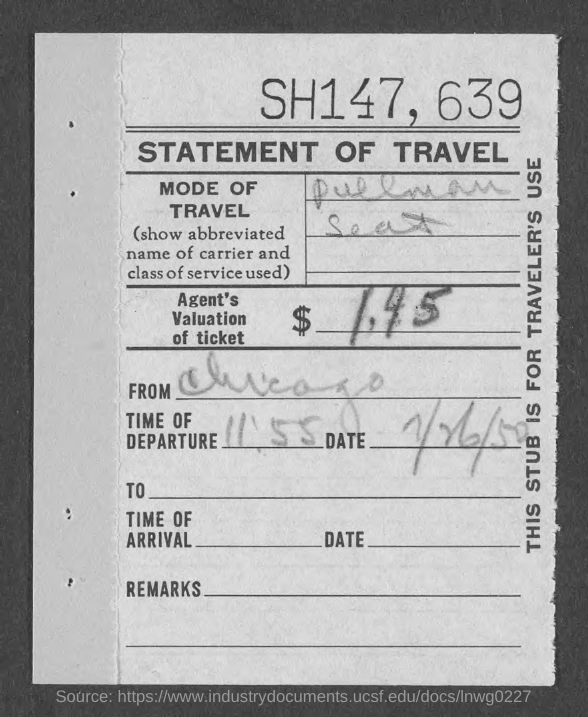Identify some key points in this picture. The time of departure is 11 minutes and 55 seconds. The value of the ticket, as assessed by the Agent, is $1.45. The mode of travel is a Pullman seat. The title of the document is a Statement of Travel. 